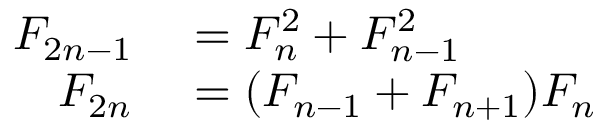Convert formula to latex. <formula><loc_0><loc_0><loc_500><loc_500>\begin{array} { r l } { F _ { 2 n - 1 } } & = F _ { n } ^ { 2 } + F _ { n - 1 } ^ { 2 } } \\ { F _ { 2 n } } & = ( F _ { n - 1 } + F _ { n + 1 } ) F _ { n } } \end{array}</formula> 